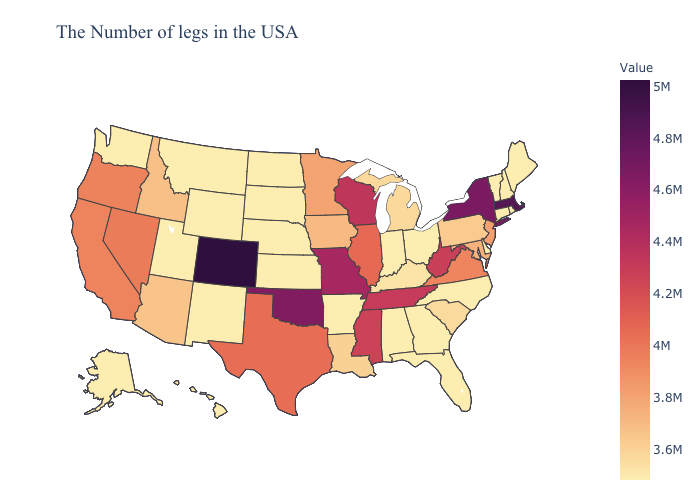Does Colorado have the highest value in the USA?
Quick response, please. Yes. Does Connecticut have the highest value in the Northeast?
Short answer required. No. Does Missouri have a higher value than New York?
Give a very brief answer. No. Does Kansas have the highest value in the MidWest?
Be succinct. No. Among the states that border Utah , which have the highest value?
Answer briefly. Colorado. Does Georgia have a lower value than Oregon?
Quick response, please. Yes. Does Alabama have the lowest value in the South?
Concise answer only. Yes. Does Michigan have the lowest value in the MidWest?
Answer briefly. No. Does Kansas have the highest value in the USA?
Short answer required. No. 